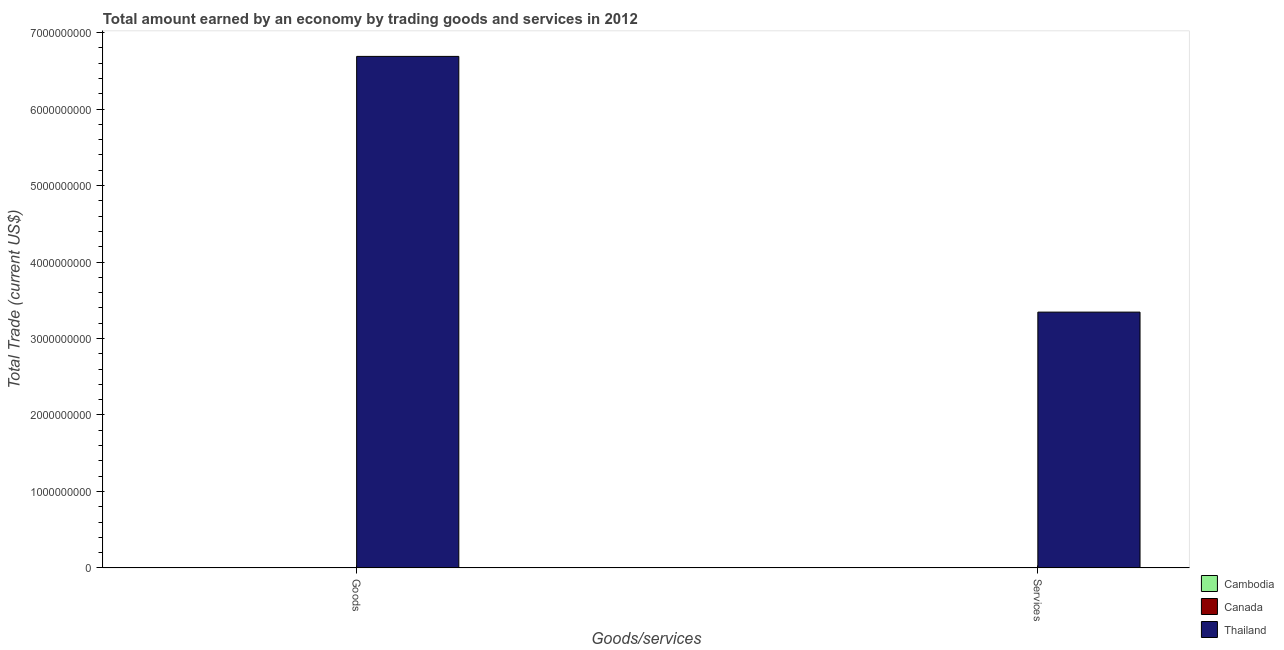Are the number of bars per tick equal to the number of legend labels?
Keep it short and to the point. No. Are the number of bars on each tick of the X-axis equal?
Ensure brevity in your answer.  Yes. How many bars are there on the 1st tick from the left?
Your answer should be very brief. 1. How many bars are there on the 1st tick from the right?
Offer a very short reply. 1. What is the label of the 1st group of bars from the left?
Offer a very short reply. Goods. Across all countries, what is the maximum amount earned by trading goods?
Keep it short and to the point. 6.69e+09. In which country was the amount earned by trading goods maximum?
Offer a terse response. Thailand. What is the total amount earned by trading services in the graph?
Offer a terse response. 3.34e+09. What is the difference between the amount earned by trading goods in Canada and the amount earned by trading services in Thailand?
Your answer should be very brief. -3.34e+09. What is the average amount earned by trading goods per country?
Give a very brief answer. 2.23e+09. What is the difference between the amount earned by trading services and amount earned by trading goods in Thailand?
Your answer should be very brief. -3.34e+09. In how many countries, is the amount earned by trading goods greater than 4800000000 US$?
Offer a very short reply. 1. How many bars are there?
Offer a very short reply. 2. Are all the bars in the graph horizontal?
Provide a short and direct response. No. Does the graph contain grids?
Your answer should be very brief. No. Where does the legend appear in the graph?
Your answer should be very brief. Bottom right. How many legend labels are there?
Ensure brevity in your answer.  3. What is the title of the graph?
Your response must be concise. Total amount earned by an economy by trading goods and services in 2012. Does "Virgin Islands" appear as one of the legend labels in the graph?
Give a very brief answer. No. What is the label or title of the X-axis?
Offer a terse response. Goods/services. What is the label or title of the Y-axis?
Ensure brevity in your answer.  Total Trade (current US$). What is the Total Trade (current US$) of Thailand in Goods?
Your answer should be very brief. 6.69e+09. What is the Total Trade (current US$) in Cambodia in Services?
Provide a succinct answer. 0. What is the Total Trade (current US$) of Canada in Services?
Your response must be concise. 0. What is the Total Trade (current US$) in Thailand in Services?
Your answer should be very brief. 3.34e+09. Across all Goods/services, what is the maximum Total Trade (current US$) in Thailand?
Keep it short and to the point. 6.69e+09. Across all Goods/services, what is the minimum Total Trade (current US$) in Thailand?
Your answer should be compact. 3.34e+09. What is the total Total Trade (current US$) in Cambodia in the graph?
Your response must be concise. 0. What is the total Total Trade (current US$) in Canada in the graph?
Give a very brief answer. 0. What is the total Total Trade (current US$) of Thailand in the graph?
Offer a very short reply. 1.00e+1. What is the difference between the Total Trade (current US$) in Thailand in Goods and that in Services?
Offer a very short reply. 3.34e+09. What is the average Total Trade (current US$) of Thailand per Goods/services?
Ensure brevity in your answer.  5.02e+09. What is the ratio of the Total Trade (current US$) in Thailand in Goods to that in Services?
Give a very brief answer. 2. What is the difference between the highest and the second highest Total Trade (current US$) of Thailand?
Your answer should be very brief. 3.34e+09. What is the difference between the highest and the lowest Total Trade (current US$) of Thailand?
Give a very brief answer. 3.34e+09. 